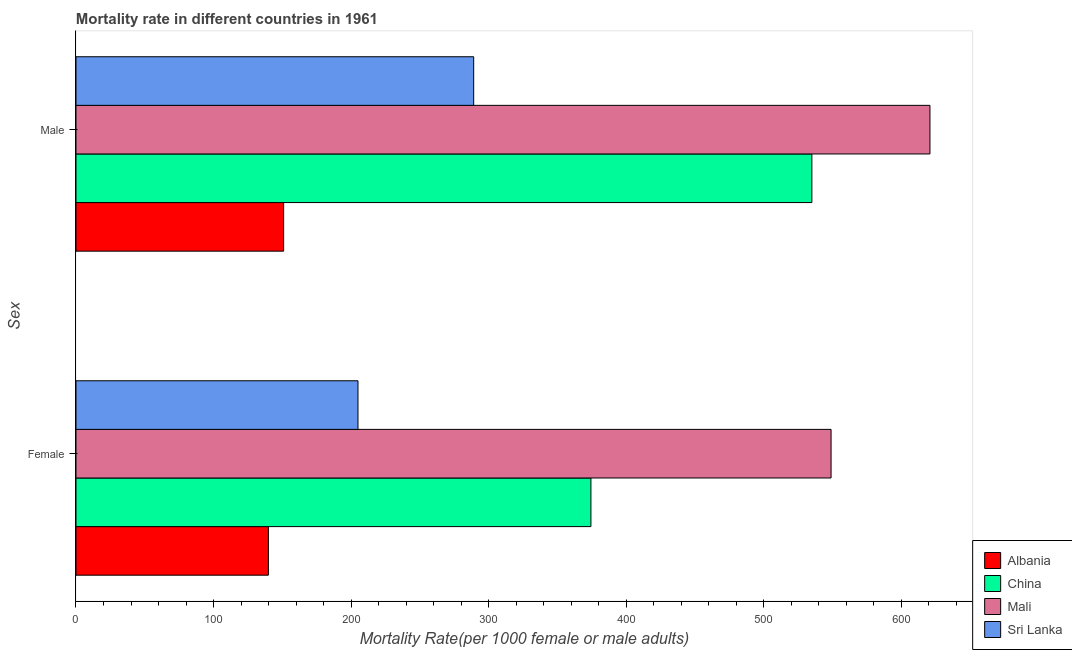How many different coloured bars are there?
Offer a terse response. 4. How many groups of bars are there?
Keep it short and to the point. 2. What is the male mortality rate in Albania?
Ensure brevity in your answer.  150.94. Across all countries, what is the maximum female mortality rate?
Offer a terse response. 548.86. Across all countries, what is the minimum female mortality rate?
Your response must be concise. 139.86. In which country was the male mortality rate maximum?
Give a very brief answer. Mali. In which country was the female mortality rate minimum?
Provide a short and direct response. Albania. What is the total female mortality rate in the graph?
Provide a short and direct response. 1268. What is the difference between the male mortality rate in Mali and that in China?
Make the answer very short. 85.83. What is the difference between the male mortality rate in Albania and the female mortality rate in Mali?
Provide a short and direct response. -397.92. What is the average female mortality rate per country?
Ensure brevity in your answer.  317. What is the difference between the male mortality rate and female mortality rate in Albania?
Keep it short and to the point. 11.09. In how many countries, is the male mortality rate greater than 280 ?
Your answer should be very brief. 3. What is the ratio of the female mortality rate in Albania to that in China?
Offer a very short reply. 0.37. Is the female mortality rate in Albania less than that in China?
Provide a succinct answer. Yes. What does the 2nd bar from the top in Male represents?
Provide a short and direct response. Mali. What does the 1st bar from the bottom in Male represents?
Your response must be concise. Albania. How many bars are there?
Your answer should be compact. 8. Are all the bars in the graph horizontal?
Provide a succinct answer. Yes. How many countries are there in the graph?
Your response must be concise. 4. What is the difference between two consecutive major ticks on the X-axis?
Offer a very short reply. 100. Does the graph contain any zero values?
Keep it short and to the point. No. How are the legend labels stacked?
Make the answer very short. Vertical. What is the title of the graph?
Provide a short and direct response. Mortality rate in different countries in 1961. What is the label or title of the X-axis?
Ensure brevity in your answer.  Mortality Rate(per 1000 female or male adults). What is the label or title of the Y-axis?
Ensure brevity in your answer.  Sex. What is the Mortality Rate(per 1000 female or male adults) of Albania in Female?
Offer a very short reply. 139.86. What is the Mortality Rate(per 1000 female or male adults) in China in Female?
Offer a terse response. 374.3. What is the Mortality Rate(per 1000 female or male adults) of Mali in Female?
Keep it short and to the point. 548.86. What is the Mortality Rate(per 1000 female or male adults) in Sri Lanka in Female?
Give a very brief answer. 204.98. What is the Mortality Rate(per 1000 female or male adults) of Albania in Male?
Keep it short and to the point. 150.94. What is the Mortality Rate(per 1000 female or male adults) of China in Male?
Keep it short and to the point. 534.91. What is the Mortality Rate(per 1000 female or male adults) of Mali in Male?
Your answer should be compact. 620.74. What is the Mortality Rate(per 1000 female or male adults) in Sri Lanka in Male?
Give a very brief answer. 289.09. Across all Sex, what is the maximum Mortality Rate(per 1000 female or male adults) in Albania?
Keep it short and to the point. 150.94. Across all Sex, what is the maximum Mortality Rate(per 1000 female or male adults) in China?
Give a very brief answer. 534.91. Across all Sex, what is the maximum Mortality Rate(per 1000 female or male adults) of Mali?
Give a very brief answer. 620.74. Across all Sex, what is the maximum Mortality Rate(per 1000 female or male adults) of Sri Lanka?
Make the answer very short. 289.09. Across all Sex, what is the minimum Mortality Rate(per 1000 female or male adults) in Albania?
Offer a terse response. 139.86. Across all Sex, what is the minimum Mortality Rate(per 1000 female or male adults) of China?
Your response must be concise. 374.3. Across all Sex, what is the minimum Mortality Rate(per 1000 female or male adults) in Mali?
Offer a terse response. 548.86. Across all Sex, what is the minimum Mortality Rate(per 1000 female or male adults) in Sri Lanka?
Keep it short and to the point. 204.98. What is the total Mortality Rate(per 1000 female or male adults) in Albania in the graph?
Offer a very short reply. 290.8. What is the total Mortality Rate(per 1000 female or male adults) in China in the graph?
Your answer should be very brief. 909.21. What is the total Mortality Rate(per 1000 female or male adults) in Mali in the graph?
Your answer should be compact. 1169.6. What is the total Mortality Rate(per 1000 female or male adults) of Sri Lanka in the graph?
Make the answer very short. 494.07. What is the difference between the Mortality Rate(per 1000 female or male adults) in Albania in Female and that in Male?
Provide a short and direct response. -11.09. What is the difference between the Mortality Rate(per 1000 female or male adults) of China in Female and that in Male?
Your answer should be compact. -160.61. What is the difference between the Mortality Rate(per 1000 female or male adults) in Mali in Female and that in Male?
Provide a succinct answer. -71.88. What is the difference between the Mortality Rate(per 1000 female or male adults) in Sri Lanka in Female and that in Male?
Give a very brief answer. -84.1. What is the difference between the Mortality Rate(per 1000 female or male adults) of Albania in Female and the Mortality Rate(per 1000 female or male adults) of China in Male?
Your response must be concise. -395.05. What is the difference between the Mortality Rate(per 1000 female or male adults) in Albania in Female and the Mortality Rate(per 1000 female or male adults) in Mali in Male?
Provide a succinct answer. -480.89. What is the difference between the Mortality Rate(per 1000 female or male adults) in Albania in Female and the Mortality Rate(per 1000 female or male adults) in Sri Lanka in Male?
Provide a succinct answer. -149.23. What is the difference between the Mortality Rate(per 1000 female or male adults) of China in Female and the Mortality Rate(per 1000 female or male adults) of Mali in Male?
Offer a terse response. -246.44. What is the difference between the Mortality Rate(per 1000 female or male adults) in China in Female and the Mortality Rate(per 1000 female or male adults) in Sri Lanka in Male?
Your answer should be very brief. 85.21. What is the difference between the Mortality Rate(per 1000 female or male adults) in Mali in Female and the Mortality Rate(per 1000 female or male adults) in Sri Lanka in Male?
Your response must be concise. 259.77. What is the average Mortality Rate(per 1000 female or male adults) in Albania per Sex?
Ensure brevity in your answer.  145.4. What is the average Mortality Rate(per 1000 female or male adults) in China per Sex?
Offer a terse response. 454.61. What is the average Mortality Rate(per 1000 female or male adults) of Mali per Sex?
Your answer should be very brief. 584.8. What is the average Mortality Rate(per 1000 female or male adults) of Sri Lanka per Sex?
Your response must be concise. 247.04. What is the difference between the Mortality Rate(per 1000 female or male adults) of Albania and Mortality Rate(per 1000 female or male adults) of China in Female?
Make the answer very short. -234.45. What is the difference between the Mortality Rate(per 1000 female or male adults) of Albania and Mortality Rate(per 1000 female or male adults) of Mali in Female?
Offer a terse response. -409. What is the difference between the Mortality Rate(per 1000 female or male adults) of Albania and Mortality Rate(per 1000 female or male adults) of Sri Lanka in Female?
Offer a terse response. -65.13. What is the difference between the Mortality Rate(per 1000 female or male adults) in China and Mortality Rate(per 1000 female or male adults) in Mali in Female?
Your answer should be very brief. -174.56. What is the difference between the Mortality Rate(per 1000 female or male adults) in China and Mortality Rate(per 1000 female or male adults) in Sri Lanka in Female?
Offer a very short reply. 169.32. What is the difference between the Mortality Rate(per 1000 female or male adults) in Mali and Mortality Rate(per 1000 female or male adults) in Sri Lanka in Female?
Your answer should be very brief. 343.88. What is the difference between the Mortality Rate(per 1000 female or male adults) of Albania and Mortality Rate(per 1000 female or male adults) of China in Male?
Provide a short and direct response. -383.96. What is the difference between the Mortality Rate(per 1000 female or male adults) in Albania and Mortality Rate(per 1000 female or male adults) in Mali in Male?
Offer a very short reply. -469.8. What is the difference between the Mortality Rate(per 1000 female or male adults) in Albania and Mortality Rate(per 1000 female or male adults) in Sri Lanka in Male?
Ensure brevity in your answer.  -138.15. What is the difference between the Mortality Rate(per 1000 female or male adults) in China and Mortality Rate(per 1000 female or male adults) in Mali in Male?
Your answer should be very brief. -85.83. What is the difference between the Mortality Rate(per 1000 female or male adults) in China and Mortality Rate(per 1000 female or male adults) in Sri Lanka in Male?
Give a very brief answer. 245.82. What is the difference between the Mortality Rate(per 1000 female or male adults) of Mali and Mortality Rate(per 1000 female or male adults) of Sri Lanka in Male?
Keep it short and to the point. 331.65. What is the ratio of the Mortality Rate(per 1000 female or male adults) of Albania in Female to that in Male?
Keep it short and to the point. 0.93. What is the ratio of the Mortality Rate(per 1000 female or male adults) of China in Female to that in Male?
Ensure brevity in your answer.  0.7. What is the ratio of the Mortality Rate(per 1000 female or male adults) in Mali in Female to that in Male?
Offer a very short reply. 0.88. What is the ratio of the Mortality Rate(per 1000 female or male adults) in Sri Lanka in Female to that in Male?
Provide a short and direct response. 0.71. What is the difference between the highest and the second highest Mortality Rate(per 1000 female or male adults) in Albania?
Your response must be concise. 11.09. What is the difference between the highest and the second highest Mortality Rate(per 1000 female or male adults) in China?
Provide a short and direct response. 160.61. What is the difference between the highest and the second highest Mortality Rate(per 1000 female or male adults) in Mali?
Provide a succinct answer. 71.88. What is the difference between the highest and the second highest Mortality Rate(per 1000 female or male adults) of Sri Lanka?
Your answer should be compact. 84.1. What is the difference between the highest and the lowest Mortality Rate(per 1000 female or male adults) of Albania?
Give a very brief answer. 11.09. What is the difference between the highest and the lowest Mortality Rate(per 1000 female or male adults) in China?
Ensure brevity in your answer.  160.61. What is the difference between the highest and the lowest Mortality Rate(per 1000 female or male adults) of Mali?
Offer a terse response. 71.88. What is the difference between the highest and the lowest Mortality Rate(per 1000 female or male adults) of Sri Lanka?
Offer a very short reply. 84.1. 